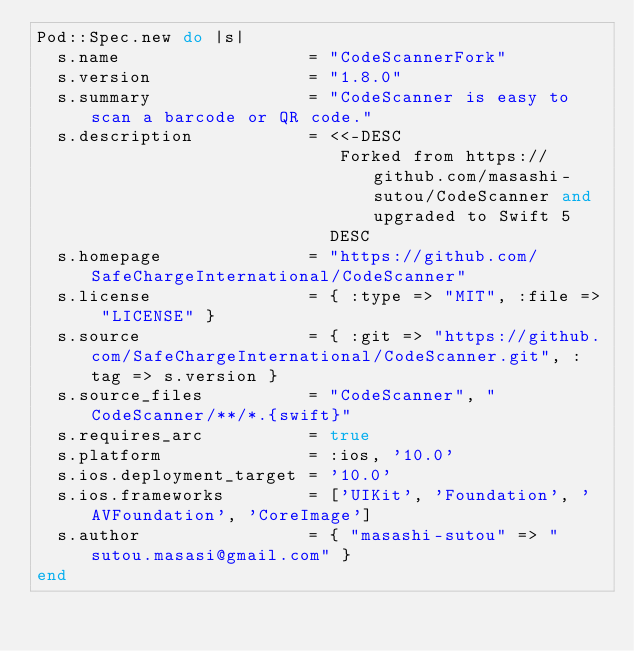<code> <loc_0><loc_0><loc_500><loc_500><_Ruby_>Pod::Spec.new do |s|
  s.name                  = "CodeScannerFork"
  s.version               = "1.8.0"
  s.summary               = "CodeScanner is easy to scan a barcode or QR code."
  s.description           = <<-DESC
                             Forked from https://github.com/masashi-sutou/CodeScanner and upgraded to Swift 5
                            DESC
  s.homepage              = "https://github.com/SafeChargeInternational/CodeScanner"
  s.license               = { :type => "MIT", :file => "LICENSE" }
  s.source                = { :git => "https://github.com/SafeChargeInternational/CodeScanner.git", :tag => s.version }
  s.source_files          = "CodeScanner", "CodeScanner/**/*.{swift}"
  s.requires_arc          = true
  s.platform              = :ios, '10.0'
  s.ios.deployment_target = '10.0'
  s.ios.frameworks        = ['UIKit', 'Foundation', 'AVFoundation', 'CoreImage']
  s.author                = { "masashi-sutou" => "sutou.masasi@gmail.com" }
end
</code> 